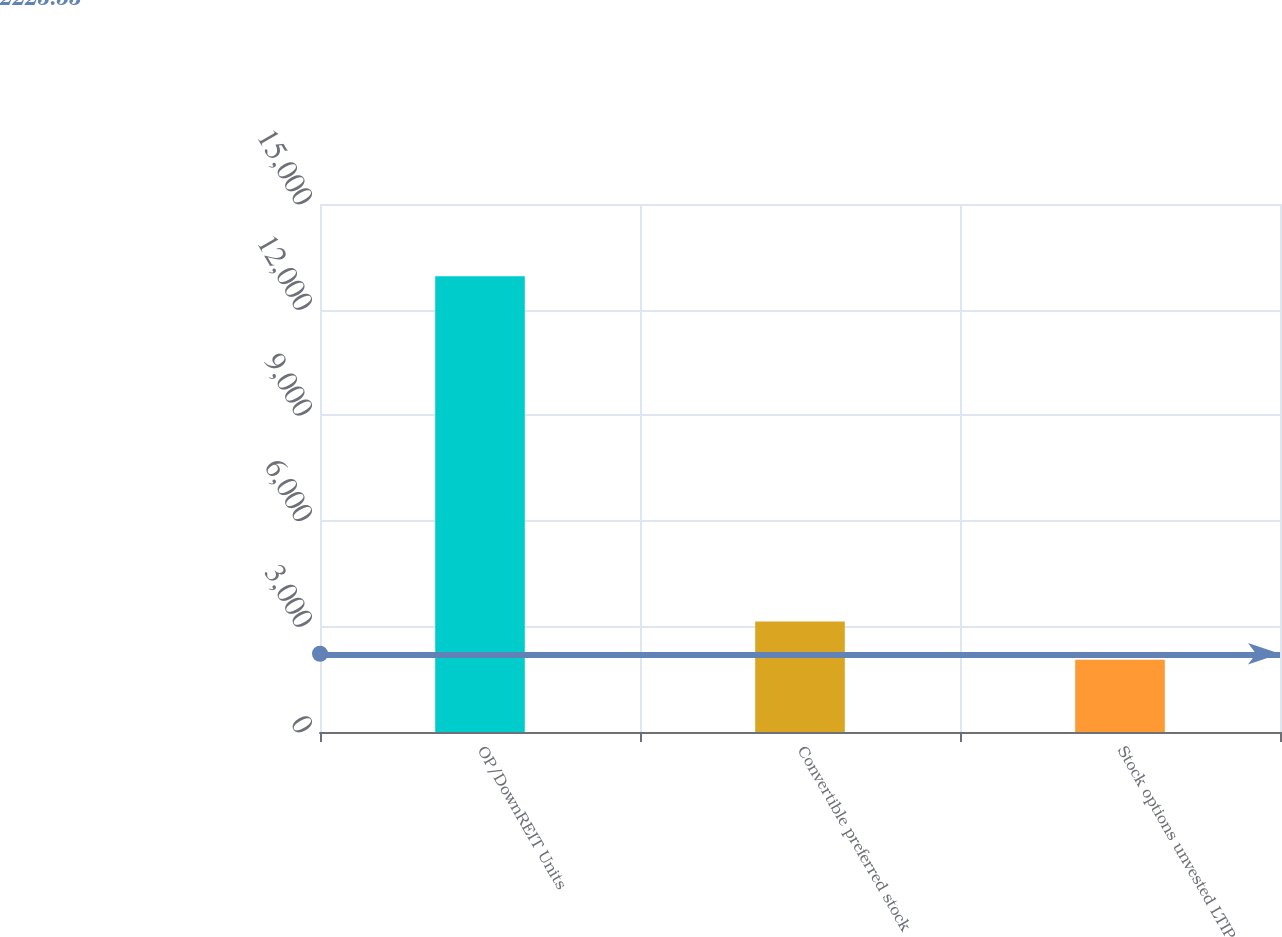<chart> <loc_0><loc_0><loc_500><loc_500><bar_chart><fcel>OP/DownREIT Units<fcel>Convertible preferred stock<fcel>Stock options unvested LTIP<nl><fcel>12947<fcel>3140.6<fcel>2051<nl></chart> 